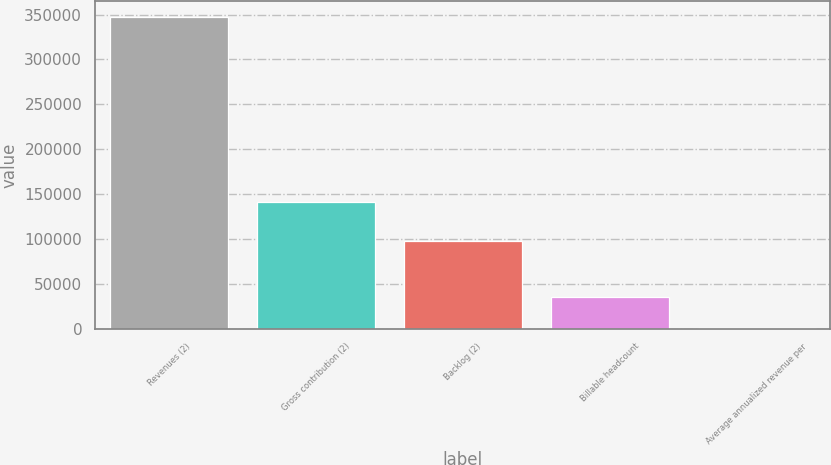<chart> <loc_0><loc_0><loc_500><loc_500><bar_chart><fcel>Revenues (2)<fcel>Gross contribution (2)<fcel>Backlog (2)<fcel>Billable headcount<fcel>Average annualized revenue per<nl><fcel>347404<fcel>141395<fcel>97169<fcel>35154.4<fcel>460<nl></chart> 